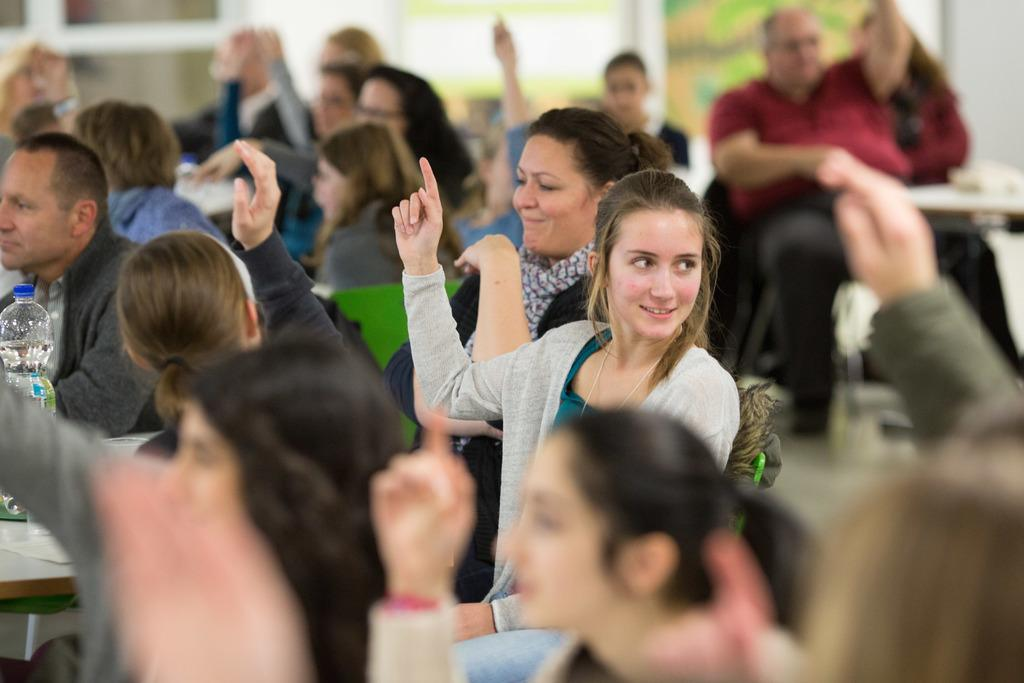How many people are in the image? There is a group of people in the image. What are the people wearing? The people are wearing clothes. What object can be seen on a table in the image? There is a bottle on a table in the image. Where is the table located in the image? The table is in the bottom left of the image. How would you describe the background of the image? The background of the image is blurred. What type of skirt is the star wearing in the image? There is no star or skirt present in the image. What is inside the box that is visible in the image? There is no box present in the image. 